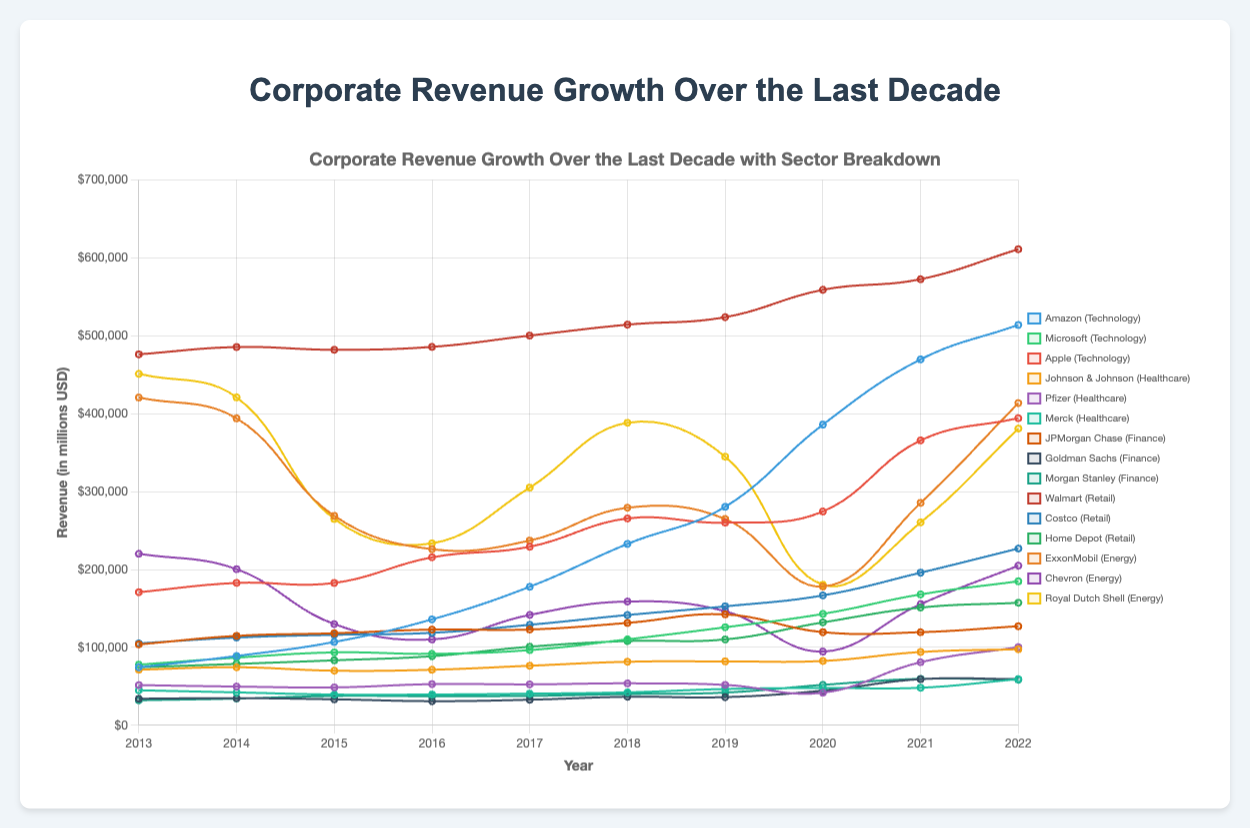What company had the highest revenue in 2022? To determine this, look at the values on the y-axis for the year 2022 for each company and compare them. The highest revenue among all the companies in 2022 is from Walmart.
Answer: Walmart Which sector showed the most consistent growth over the entire decade? Examine the trend lines for each sector. The sector with the most consistent upward trajectory without significant fluctuations is Technology, particularly companies like Amazon and Microsoft.
Answer: Technology Between 2019 and 2020, which company in the Energy sector had the most significant revenue decline? Compare the revenue values for 2019 and 2020 for ExxonMobil, Chevron, and Royal Dutch Shell. Royal Dutch Shell had the most significant decline from 344,877 million USD in 2019 to 180,543 million USD in 2020.
Answer: Royal Dutch Shell What is the total revenue for Apple from 2013 to 2022? Sum the values for Apple from each year between 2013 and 2022: 170,910 + 182,795 + 182,792 + 215,639 + 229,234 + 265,595 + 260,174 + 274,515 + 365,817 + 394,328 = 2,542,799 million USD.
Answer: 2,542,799 million USD Which company in the Healthcare sector had the highest revenue in 2020? Look at the data points on the y-axis for 2020 for Johnson & Johnson, Pfizer, and Merck. Johnson & Johnson has the highest revenue in 2020.
Answer: Johnson & Johnson Which company had the most significant increase in revenue from 2013 to 2022? Calculate the difference between the revenue values for 2013 and 2022 for each company. Amazon shows the most significant increase: 514,000 - 74,452 = 439,548 million USD.
Answer: Amazon How does the revenue of Walmart in 2022 compare to the combined revenues of Home Depot and Costco in 2022? Walmart's revenue in 2022 is 611,287 million USD. The combined revenue of Home Depot and Costco in 2022 is 226,954 + 157,292 = 384,246 million USD. Walmart's revenue is significantly higher.
Answer: Walmart's revenue is higher Which sector had a company reach revenue above 400,000 million USD for the first time, and in what year? Check the timeline and revenue values for each company, focusing on when they first surpassed 400,000 million USD. Amazon in the Technology sector first surpassed 400,000 million USD in 2020.
Answer: Technology sector, 2020 Which company in the Finance sector had the highest revenue growth in 2021 compared to 2020? Calculate the difference in revenues between 2021 and 2020 for JPMorgan Chase, Goldman Sachs, and Morgan Stanley. Goldman Sachs had the highest growth: 59,223 - 44,460 = 14,763 million USD.
Answer: Goldman Sachs 